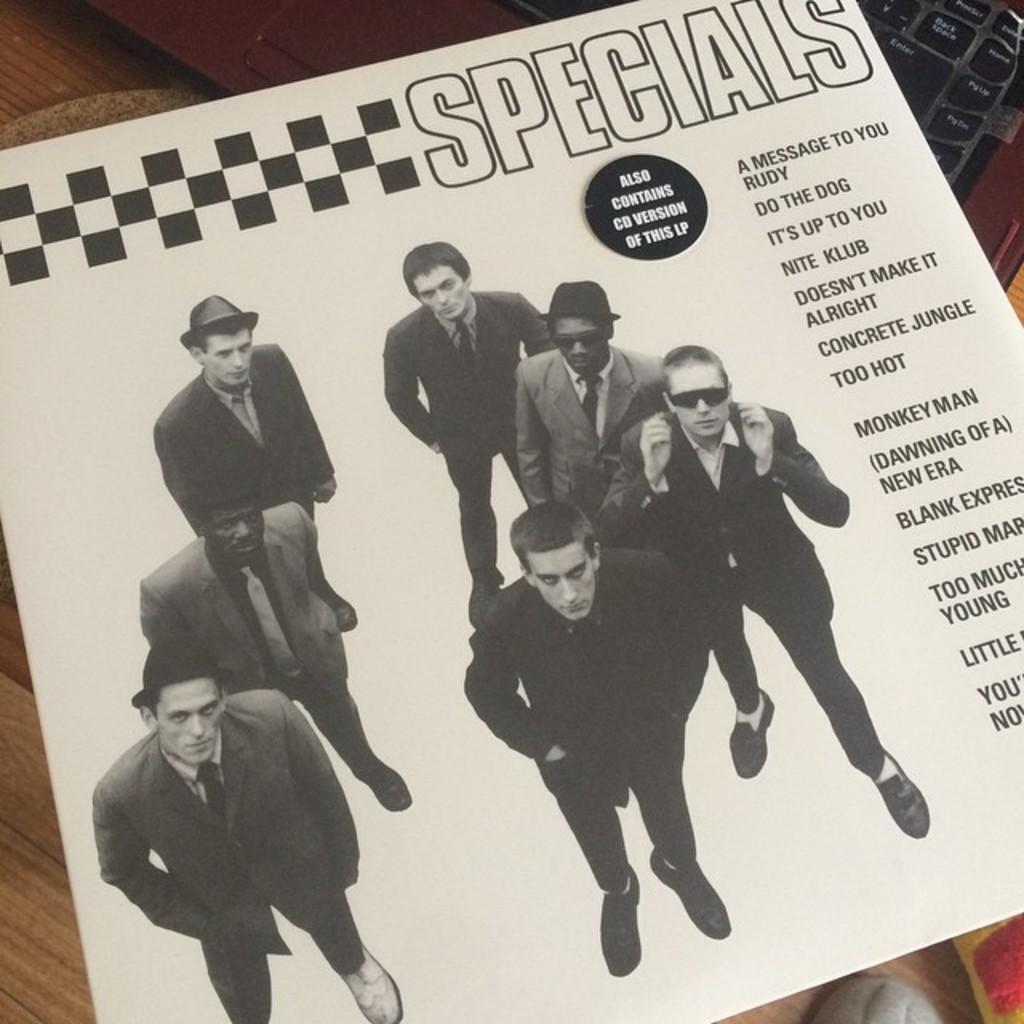Please provide a concise description of this image. In this image, there is a paper where people are printed on it and also also some text is printed on the paper. This paper is placed on the keyboard. 